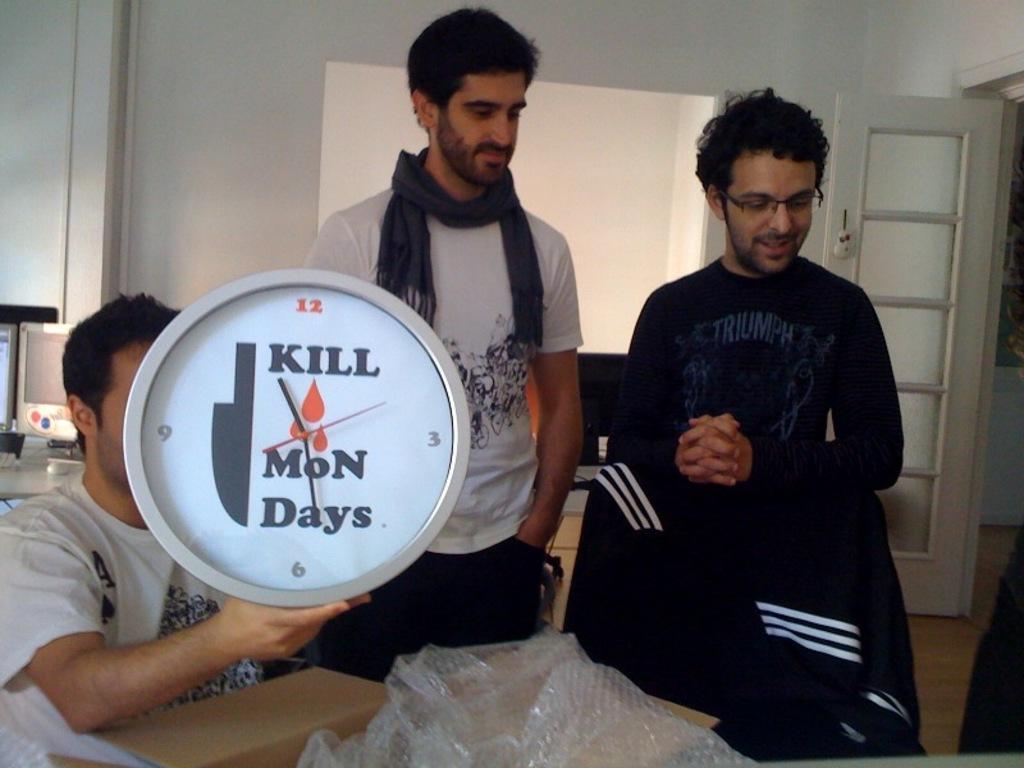Can you describe this image briefly? In this image there are two persons standing, a person sitting and holding a clock, and there is a cardboard box, chair, and in the background there are monitors on the table and there is a door. 